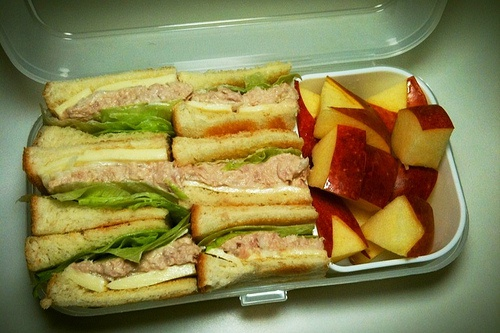Describe the objects in this image and their specific colors. I can see bowl in black, tan, olive, and maroon tones, apple in black, maroon, olive, and orange tones, sandwich in black, olive, and tan tones, sandwich in black, tan, olive, and khaki tones, and sandwich in black, tan, khaki, and red tones in this image. 